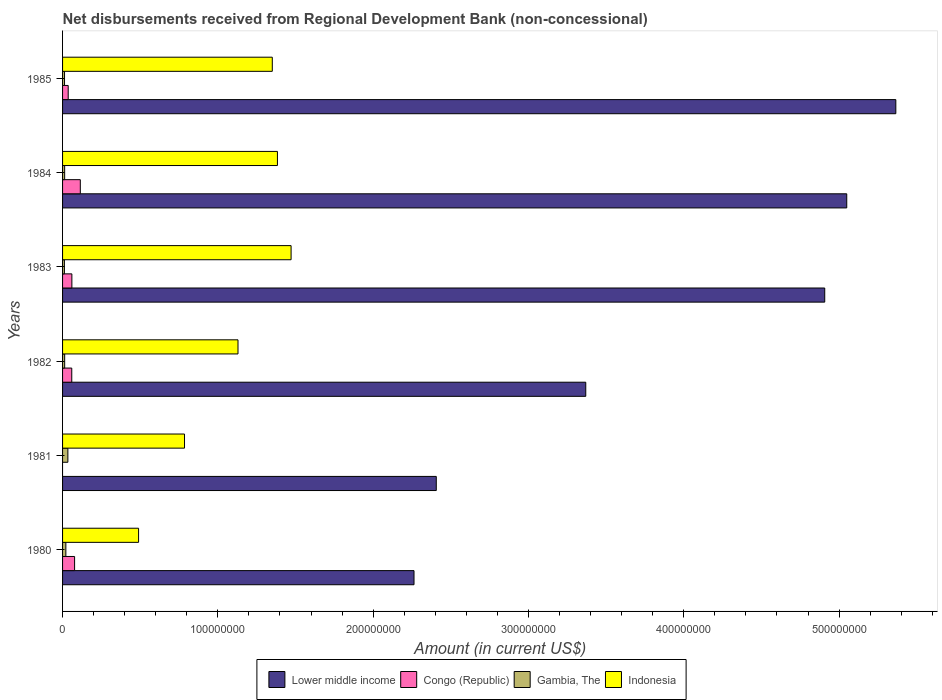Are the number of bars per tick equal to the number of legend labels?
Make the answer very short. No. Are the number of bars on each tick of the Y-axis equal?
Keep it short and to the point. No. What is the label of the 2nd group of bars from the top?
Make the answer very short. 1984. What is the amount of disbursements received from Regional Development Bank in Lower middle income in 1981?
Your answer should be compact. 2.41e+08. Across all years, what is the maximum amount of disbursements received from Regional Development Bank in Lower middle income?
Keep it short and to the point. 5.37e+08. Across all years, what is the minimum amount of disbursements received from Regional Development Bank in Gambia, The?
Your response must be concise. 1.18e+06. In which year was the amount of disbursements received from Regional Development Bank in Indonesia maximum?
Offer a terse response. 1983. What is the total amount of disbursements received from Regional Development Bank in Indonesia in the graph?
Provide a succinct answer. 6.61e+08. What is the difference between the amount of disbursements received from Regional Development Bank in Congo (Republic) in 1982 and that in 1984?
Offer a very short reply. -5.50e+06. What is the difference between the amount of disbursements received from Regional Development Bank in Congo (Republic) in 1985 and the amount of disbursements received from Regional Development Bank in Indonesia in 1983?
Offer a terse response. -1.44e+08. What is the average amount of disbursements received from Regional Development Bank in Gambia, The per year?
Keep it short and to the point. 1.78e+06. In the year 1980, what is the difference between the amount of disbursements received from Regional Development Bank in Gambia, The and amount of disbursements received from Regional Development Bank in Congo (Republic)?
Give a very brief answer. -5.63e+06. In how many years, is the amount of disbursements received from Regional Development Bank in Gambia, The greater than 140000000 US$?
Your answer should be compact. 0. What is the ratio of the amount of disbursements received from Regional Development Bank in Congo (Republic) in 1982 to that in 1983?
Your answer should be very brief. 0.99. Is the amount of disbursements received from Regional Development Bank in Indonesia in 1984 less than that in 1985?
Offer a terse response. No. Is the difference between the amount of disbursements received from Regional Development Bank in Gambia, The in 1983 and 1984 greater than the difference between the amount of disbursements received from Regional Development Bank in Congo (Republic) in 1983 and 1984?
Keep it short and to the point. Yes. What is the difference between the highest and the second highest amount of disbursements received from Regional Development Bank in Congo (Republic)?
Your answer should be compact. 3.68e+06. What is the difference between the highest and the lowest amount of disbursements received from Regional Development Bank in Indonesia?
Offer a terse response. 9.82e+07. How many bars are there?
Provide a short and direct response. 23. How many years are there in the graph?
Keep it short and to the point. 6. What is the difference between two consecutive major ticks on the X-axis?
Your answer should be compact. 1.00e+08. Does the graph contain grids?
Ensure brevity in your answer.  No. Where does the legend appear in the graph?
Your answer should be very brief. Bottom center. How many legend labels are there?
Ensure brevity in your answer.  4. How are the legend labels stacked?
Give a very brief answer. Horizontal. What is the title of the graph?
Offer a very short reply. Net disbursements received from Regional Development Bank (non-concessional). Does "Micronesia" appear as one of the legend labels in the graph?
Ensure brevity in your answer.  No. What is the label or title of the X-axis?
Give a very brief answer. Amount (in current US$). What is the Amount (in current US$) in Lower middle income in 1980?
Offer a very short reply. 2.26e+08. What is the Amount (in current US$) in Congo (Republic) in 1980?
Your response must be concise. 7.74e+06. What is the Amount (in current US$) of Gambia, The in 1980?
Provide a short and direct response. 2.12e+06. What is the Amount (in current US$) in Indonesia in 1980?
Keep it short and to the point. 4.89e+07. What is the Amount (in current US$) in Lower middle income in 1981?
Offer a very short reply. 2.41e+08. What is the Amount (in current US$) in Congo (Republic) in 1981?
Offer a terse response. 0. What is the Amount (in current US$) in Gambia, The in 1981?
Provide a short and direct response. 3.42e+06. What is the Amount (in current US$) of Indonesia in 1981?
Your answer should be compact. 7.85e+07. What is the Amount (in current US$) of Lower middle income in 1982?
Offer a terse response. 3.37e+08. What is the Amount (in current US$) in Congo (Republic) in 1982?
Offer a terse response. 5.92e+06. What is the Amount (in current US$) of Gambia, The in 1982?
Your response must be concise. 1.36e+06. What is the Amount (in current US$) of Indonesia in 1982?
Keep it short and to the point. 1.13e+08. What is the Amount (in current US$) of Lower middle income in 1983?
Give a very brief answer. 4.91e+08. What is the Amount (in current US$) in Congo (Republic) in 1983?
Provide a succinct answer. 6.00e+06. What is the Amount (in current US$) in Gambia, The in 1983?
Ensure brevity in your answer.  1.18e+06. What is the Amount (in current US$) in Indonesia in 1983?
Your answer should be compact. 1.47e+08. What is the Amount (in current US$) of Lower middle income in 1984?
Offer a terse response. 5.05e+08. What is the Amount (in current US$) in Congo (Republic) in 1984?
Your answer should be compact. 1.14e+07. What is the Amount (in current US$) of Gambia, The in 1984?
Provide a short and direct response. 1.35e+06. What is the Amount (in current US$) in Indonesia in 1984?
Offer a terse response. 1.38e+08. What is the Amount (in current US$) of Lower middle income in 1985?
Make the answer very short. 5.37e+08. What is the Amount (in current US$) in Congo (Republic) in 1985?
Your answer should be very brief. 3.63e+06. What is the Amount (in current US$) of Gambia, The in 1985?
Provide a short and direct response. 1.26e+06. What is the Amount (in current US$) of Indonesia in 1985?
Your answer should be compact. 1.35e+08. Across all years, what is the maximum Amount (in current US$) in Lower middle income?
Provide a short and direct response. 5.37e+08. Across all years, what is the maximum Amount (in current US$) of Congo (Republic)?
Your answer should be very brief. 1.14e+07. Across all years, what is the maximum Amount (in current US$) in Gambia, The?
Your response must be concise. 3.42e+06. Across all years, what is the maximum Amount (in current US$) of Indonesia?
Ensure brevity in your answer.  1.47e+08. Across all years, what is the minimum Amount (in current US$) of Lower middle income?
Your response must be concise. 2.26e+08. Across all years, what is the minimum Amount (in current US$) of Gambia, The?
Your answer should be very brief. 1.18e+06. Across all years, what is the minimum Amount (in current US$) of Indonesia?
Give a very brief answer. 4.89e+07. What is the total Amount (in current US$) of Lower middle income in the graph?
Your answer should be compact. 2.34e+09. What is the total Amount (in current US$) in Congo (Republic) in the graph?
Provide a short and direct response. 3.47e+07. What is the total Amount (in current US$) in Gambia, The in the graph?
Offer a terse response. 1.07e+07. What is the total Amount (in current US$) of Indonesia in the graph?
Provide a succinct answer. 6.61e+08. What is the difference between the Amount (in current US$) of Lower middle income in 1980 and that in 1981?
Offer a very short reply. -1.43e+07. What is the difference between the Amount (in current US$) in Gambia, The in 1980 and that in 1981?
Offer a very short reply. -1.30e+06. What is the difference between the Amount (in current US$) of Indonesia in 1980 and that in 1981?
Provide a short and direct response. -2.96e+07. What is the difference between the Amount (in current US$) of Lower middle income in 1980 and that in 1982?
Give a very brief answer. -1.11e+08. What is the difference between the Amount (in current US$) in Congo (Republic) in 1980 and that in 1982?
Keep it short and to the point. 1.82e+06. What is the difference between the Amount (in current US$) of Gambia, The in 1980 and that in 1982?
Your response must be concise. 7.58e+05. What is the difference between the Amount (in current US$) of Indonesia in 1980 and that in 1982?
Provide a short and direct response. -6.40e+07. What is the difference between the Amount (in current US$) in Lower middle income in 1980 and that in 1983?
Your answer should be very brief. -2.64e+08. What is the difference between the Amount (in current US$) of Congo (Republic) in 1980 and that in 1983?
Make the answer very short. 1.75e+06. What is the difference between the Amount (in current US$) in Gambia, The in 1980 and that in 1983?
Your answer should be very brief. 9.31e+05. What is the difference between the Amount (in current US$) of Indonesia in 1980 and that in 1983?
Provide a succinct answer. -9.82e+07. What is the difference between the Amount (in current US$) in Lower middle income in 1980 and that in 1984?
Your answer should be very brief. -2.79e+08. What is the difference between the Amount (in current US$) of Congo (Republic) in 1980 and that in 1984?
Ensure brevity in your answer.  -3.68e+06. What is the difference between the Amount (in current US$) in Gambia, The in 1980 and that in 1984?
Offer a terse response. 7.68e+05. What is the difference between the Amount (in current US$) in Indonesia in 1980 and that in 1984?
Ensure brevity in your answer.  -8.94e+07. What is the difference between the Amount (in current US$) in Lower middle income in 1980 and that in 1985?
Provide a succinct answer. -3.10e+08. What is the difference between the Amount (in current US$) of Congo (Republic) in 1980 and that in 1985?
Your answer should be compact. 4.12e+06. What is the difference between the Amount (in current US$) of Gambia, The in 1980 and that in 1985?
Your response must be concise. 8.53e+05. What is the difference between the Amount (in current US$) in Indonesia in 1980 and that in 1985?
Make the answer very short. -8.61e+07. What is the difference between the Amount (in current US$) of Lower middle income in 1981 and that in 1982?
Offer a very short reply. -9.63e+07. What is the difference between the Amount (in current US$) in Gambia, The in 1981 and that in 1982?
Offer a very short reply. 2.06e+06. What is the difference between the Amount (in current US$) of Indonesia in 1981 and that in 1982?
Provide a short and direct response. -3.44e+07. What is the difference between the Amount (in current US$) of Lower middle income in 1981 and that in 1983?
Provide a succinct answer. -2.50e+08. What is the difference between the Amount (in current US$) in Gambia, The in 1981 and that in 1983?
Provide a succinct answer. 2.23e+06. What is the difference between the Amount (in current US$) in Indonesia in 1981 and that in 1983?
Offer a terse response. -6.86e+07. What is the difference between the Amount (in current US$) in Lower middle income in 1981 and that in 1984?
Give a very brief answer. -2.64e+08. What is the difference between the Amount (in current US$) in Gambia, The in 1981 and that in 1984?
Ensure brevity in your answer.  2.07e+06. What is the difference between the Amount (in current US$) in Indonesia in 1981 and that in 1984?
Your response must be concise. -5.98e+07. What is the difference between the Amount (in current US$) in Lower middle income in 1981 and that in 1985?
Give a very brief answer. -2.96e+08. What is the difference between the Amount (in current US$) of Gambia, The in 1981 and that in 1985?
Provide a succinct answer. 2.16e+06. What is the difference between the Amount (in current US$) of Indonesia in 1981 and that in 1985?
Provide a succinct answer. -5.65e+07. What is the difference between the Amount (in current US$) in Lower middle income in 1982 and that in 1983?
Your response must be concise. -1.54e+08. What is the difference between the Amount (in current US$) in Congo (Republic) in 1982 and that in 1983?
Provide a succinct answer. -7.30e+04. What is the difference between the Amount (in current US$) of Gambia, The in 1982 and that in 1983?
Your response must be concise. 1.73e+05. What is the difference between the Amount (in current US$) in Indonesia in 1982 and that in 1983?
Provide a succinct answer. -3.42e+07. What is the difference between the Amount (in current US$) of Lower middle income in 1982 and that in 1984?
Give a very brief answer. -1.68e+08. What is the difference between the Amount (in current US$) of Congo (Republic) in 1982 and that in 1984?
Make the answer very short. -5.50e+06. What is the difference between the Amount (in current US$) of Gambia, The in 1982 and that in 1984?
Give a very brief answer. 10000. What is the difference between the Amount (in current US$) in Indonesia in 1982 and that in 1984?
Ensure brevity in your answer.  -2.54e+07. What is the difference between the Amount (in current US$) in Lower middle income in 1982 and that in 1985?
Ensure brevity in your answer.  -2.00e+08. What is the difference between the Amount (in current US$) in Congo (Republic) in 1982 and that in 1985?
Offer a terse response. 2.30e+06. What is the difference between the Amount (in current US$) in Gambia, The in 1982 and that in 1985?
Make the answer very short. 9.50e+04. What is the difference between the Amount (in current US$) in Indonesia in 1982 and that in 1985?
Keep it short and to the point. -2.21e+07. What is the difference between the Amount (in current US$) in Lower middle income in 1983 and that in 1984?
Your answer should be compact. -1.42e+07. What is the difference between the Amount (in current US$) of Congo (Republic) in 1983 and that in 1984?
Your response must be concise. -5.43e+06. What is the difference between the Amount (in current US$) in Gambia, The in 1983 and that in 1984?
Provide a succinct answer. -1.63e+05. What is the difference between the Amount (in current US$) in Indonesia in 1983 and that in 1984?
Your response must be concise. 8.79e+06. What is the difference between the Amount (in current US$) in Lower middle income in 1983 and that in 1985?
Make the answer very short. -4.58e+07. What is the difference between the Amount (in current US$) in Congo (Republic) in 1983 and that in 1985?
Your answer should be very brief. 2.37e+06. What is the difference between the Amount (in current US$) in Gambia, The in 1983 and that in 1985?
Offer a terse response. -7.80e+04. What is the difference between the Amount (in current US$) in Indonesia in 1983 and that in 1985?
Make the answer very short. 1.21e+07. What is the difference between the Amount (in current US$) of Lower middle income in 1984 and that in 1985?
Provide a succinct answer. -3.16e+07. What is the difference between the Amount (in current US$) in Congo (Republic) in 1984 and that in 1985?
Your answer should be very brief. 7.80e+06. What is the difference between the Amount (in current US$) in Gambia, The in 1984 and that in 1985?
Your answer should be compact. 8.50e+04. What is the difference between the Amount (in current US$) of Indonesia in 1984 and that in 1985?
Provide a succinct answer. 3.32e+06. What is the difference between the Amount (in current US$) in Lower middle income in 1980 and the Amount (in current US$) in Gambia, The in 1981?
Ensure brevity in your answer.  2.23e+08. What is the difference between the Amount (in current US$) of Lower middle income in 1980 and the Amount (in current US$) of Indonesia in 1981?
Make the answer very short. 1.48e+08. What is the difference between the Amount (in current US$) in Congo (Republic) in 1980 and the Amount (in current US$) in Gambia, The in 1981?
Offer a very short reply. 4.33e+06. What is the difference between the Amount (in current US$) in Congo (Republic) in 1980 and the Amount (in current US$) in Indonesia in 1981?
Ensure brevity in your answer.  -7.08e+07. What is the difference between the Amount (in current US$) of Gambia, The in 1980 and the Amount (in current US$) of Indonesia in 1981?
Offer a very short reply. -7.64e+07. What is the difference between the Amount (in current US$) in Lower middle income in 1980 and the Amount (in current US$) in Congo (Republic) in 1982?
Make the answer very short. 2.20e+08. What is the difference between the Amount (in current US$) in Lower middle income in 1980 and the Amount (in current US$) in Gambia, The in 1982?
Keep it short and to the point. 2.25e+08. What is the difference between the Amount (in current US$) of Lower middle income in 1980 and the Amount (in current US$) of Indonesia in 1982?
Provide a succinct answer. 1.13e+08. What is the difference between the Amount (in current US$) in Congo (Republic) in 1980 and the Amount (in current US$) in Gambia, The in 1982?
Provide a short and direct response. 6.39e+06. What is the difference between the Amount (in current US$) in Congo (Republic) in 1980 and the Amount (in current US$) in Indonesia in 1982?
Your response must be concise. -1.05e+08. What is the difference between the Amount (in current US$) in Gambia, The in 1980 and the Amount (in current US$) in Indonesia in 1982?
Your answer should be compact. -1.11e+08. What is the difference between the Amount (in current US$) in Lower middle income in 1980 and the Amount (in current US$) in Congo (Republic) in 1983?
Your response must be concise. 2.20e+08. What is the difference between the Amount (in current US$) in Lower middle income in 1980 and the Amount (in current US$) in Gambia, The in 1983?
Make the answer very short. 2.25e+08. What is the difference between the Amount (in current US$) of Lower middle income in 1980 and the Amount (in current US$) of Indonesia in 1983?
Your answer should be very brief. 7.92e+07. What is the difference between the Amount (in current US$) in Congo (Republic) in 1980 and the Amount (in current US$) in Gambia, The in 1983?
Your response must be concise. 6.56e+06. What is the difference between the Amount (in current US$) of Congo (Republic) in 1980 and the Amount (in current US$) of Indonesia in 1983?
Offer a terse response. -1.39e+08. What is the difference between the Amount (in current US$) in Gambia, The in 1980 and the Amount (in current US$) in Indonesia in 1983?
Ensure brevity in your answer.  -1.45e+08. What is the difference between the Amount (in current US$) of Lower middle income in 1980 and the Amount (in current US$) of Congo (Republic) in 1984?
Provide a succinct answer. 2.15e+08. What is the difference between the Amount (in current US$) of Lower middle income in 1980 and the Amount (in current US$) of Gambia, The in 1984?
Offer a terse response. 2.25e+08. What is the difference between the Amount (in current US$) in Lower middle income in 1980 and the Amount (in current US$) in Indonesia in 1984?
Your answer should be very brief. 8.79e+07. What is the difference between the Amount (in current US$) in Congo (Republic) in 1980 and the Amount (in current US$) in Gambia, The in 1984?
Keep it short and to the point. 6.40e+06. What is the difference between the Amount (in current US$) in Congo (Republic) in 1980 and the Amount (in current US$) in Indonesia in 1984?
Ensure brevity in your answer.  -1.31e+08. What is the difference between the Amount (in current US$) of Gambia, The in 1980 and the Amount (in current US$) of Indonesia in 1984?
Your answer should be compact. -1.36e+08. What is the difference between the Amount (in current US$) in Lower middle income in 1980 and the Amount (in current US$) in Congo (Republic) in 1985?
Provide a succinct answer. 2.23e+08. What is the difference between the Amount (in current US$) of Lower middle income in 1980 and the Amount (in current US$) of Gambia, The in 1985?
Your answer should be very brief. 2.25e+08. What is the difference between the Amount (in current US$) in Lower middle income in 1980 and the Amount (in current US$) in Indonesia in 1985?
Your answer should be very brief. 9.13e+07. What is the difference between the Amount (in current US$) in Congo (Republic) in 1980 and the Amount (in current US$) in Gambia, The in 1985?
Provide a short and direct response. 6.48e+06. What is the difference between the Amount (in current US$) in Congo (Republic) in 1980 and the Amount (in current US$) in Indonesia in 1985?
Give a very brief answer. -1.27e+08. What is the difference between the Amount (in current US$) in Gambia, The in 1980 and the Amount (in current US$) in Indonesia in 1985?
Provide a short and direct response. -1.33e+08. What is the difference between the Amount (in current US$) in Lower middle income in 1981 and the Amount (in current US$) in Congo (Republic) in 1982?
Ensure brevity in your answer.  2.35e+08. What is the difference between the Amount (in current US$) of Lower middle income in 1981 and the Amount (in current US$) of Gambia, The in 1982?
Your response must be concise. 2.39e+08. What is the difference between the Amount (in current US$) of Lower middle income in 1981 and the Amount (in current US$) of Indonesia in 1982?
Make the answer very short. 1.28e+08. What is the difference between the Amount (in current US$) of Gambia, The in 1981 and the Amount (in current US$) of Indonesia in 1982?
Your answer should be compact. -1.10e+08. What is the difference between the Amount (in current US$) of Lower middle income in 1981 and the Amount (in current US$) of Congo (Republic) in 1983?
Your answer should be very brief. 2.35e+08. What is the difference between the Amount (in current US$) of Lower middle income in 1981 and the Amount (in current US$) of Gambia, The in 1983?
Your response must be concise. 2.39e+08. What is the difference between the Amount (in current US$) in Lower middle income in 1981 and the Amount (in current US$) in Indonesia in 1983?
Ensure brevity in your answer.  9.35e+07. What is the difference between the Amount (in current US$) in Gambia, The in 1981 and the Amount (in current US$) in Indonesia in 1983?
Offer a very short reply. -1.44e+08. What is the difference between the Amount (in current US$) in Lower middle income in 1981 and the Amount (in current US$) in Congo (Republic) in 1984?
Provide a succinct answer. 2.29e+08. What is the difference between the Amount (in current US$) in Lower middle income in 1981 and the Amount (in current US$) in Gambia, The in 1984?
Ensure brevity in your answer.  2.39e+08. What is the difference between the Amount (in current US$) of Lower middle income in 1981 and the Amount (in current US$) of Indonesia in 1984?
Provide a succinct answer. 1.02e+08. What is the difference between the Amount (in current US$) in Gambia, The in 1981 and the Amount (in current US$) in Indonesia in 1984?
Offer a very short reply. -1.35e+08. What is the difference between the Amount (in current US$) in Lower middle income in 1981 and the Amount (in current US$) in Congo (Republic) in 1985?
Keep it short and to the point. 2.37e+08. What is the difference between the Amount (in current US$) of Lower middle income in 1981 and the Amount (in current US$) of Gambia, The in 1985?
Offer a very short reply. 2.39e+08. What is the difference between the Amount (in current US$) in Lower middle income in 1981 and the Amount (in current US$) in Indonesia in 1985?
Your answer should be compact. 1.06e+08. What is the difference between the Amount (in current US$) of Gambia, The in 1981 and the Amount (in current US$) of Indonesia in 1985?
Your answer should be very brief. -1.32e+08. What is the difference between the Amount (in current US$) of Lower middle income in 1982 and the Amount (in current US$) of Congo (Republic) in 1983?
Your answer should be very brief. 3.31e+08. What is the difference between the Amount (in current US$) of Lower middle income in 1982 and the Amount (in current US$) of Gambia, The in 1983?
Your response must be concise. 3.36e+08. What is the difference between the Amount (in current US$) of Lower middle income in 1982 and the Amount (in current US$) of Indonesia in 1983?
Your answer should be very brief. 1.90e+08. What is the difference between the Amount (in current US$) in Congo (Republic) in 1982 and the Amount (in current US$) in Gambia, The in 1983?
Provide a short and direct response. 4.74e+06. What is the difference between the Amount (in current US$) of Congo (Republic) in 1982 and the Amount (in current US$) of Indonesia in 1983?
Make the answer very short. -1.41e+08. What is the difference between the Amount (in current US$) of Gambia, The in 1982 and the Amount (in current US$) of Indonesia in 1983?
Make the answer very short. -1.46e+08. What is the difference between the Amount (in current US$) in Lower middle income in 1982 and the Amount (in current US$) in Congo (Republic) in 1984?
Provide a succinct answer. 3.25e+08. What is the difference between the Amount (in current US$) of Lower middle income in 1982 and the Amount (in current US$) of Gambia, The in 1984?
Provide a succinct answer. 3.36e+08. What is the difference between the Amount (in current US$) of Lower middle income in 1982 and the Amount (in current US$) of Indonesia in 1984?
Provide a succinct answer. 1.99e+08. What is the difference between the Amount (in current US$) in Congo (Republic) in 1982 and the Amount (in current US$) in Gambia, The in 1984?
Give a very brief answer. 4.57e+06. What is the difference between the Amount (in current US$) of Congo (Republic) in 1982 and the Amount (in current US$) of Indonesia in 1984?
Your answer should be very brief. -1.32e+08. What is the difference between the Amount (in current US$) in Gambia, The in 1982 and the Amount (in current US$) in Indonesia in 1984?
Provide a succinct answer. -1.37e+08. What is the difference between the Amount (in current US$) of Lower middle income in 1982 and the Amount (in current US$) of Congo (Republic) in 1985?
Your response must be concise. 3.33e+08. What is the difference between the Amount (in current US$) of Lower middle income in 1982 and the Amount (in current US$) of Gambia, The in 1985?
Your answer should be compact. 3.36e+08. What is the difference between the Amount (in current US$) in Lower middle income in 1982 and the Amount (in current US$) in Indonesia in 1985?
Your answer should be compact. 2.02e+08. What is the difference between the Amount (in current US$) in Congo (Republic) in 1982 and the Amount (in current US$) in Gambia, The in 1985?
Keep it short and to the point. 4.66e+06. What is the difference between the Amount (in current US$) in Congo (Republic) in 1982 and the Amount (in current US$) in Indonesia in 1985?
Your answer should be compact. -1.29e+08. What is the difference between the Amount (in current US$) in Gambia, The in 1982 and the Amount (in current US$) in Indonesia in 1985?
Give a very brief answer. -1.34e+08. What is the difference between the Amount (in current US$) in Lower middle income in 1983 and the Amount (in current US$) in Congo (Republic) in 1984?
Offer a very short reply. 4.79e+08. What is the difference between the Amount (in current US$) of Lower middle income in 1983 and the Amount (in current US$) of Gambia, The in 1984?
Your response must be concise. 4.89e+08. What is the difference between the Amount (in current US$) of Lower middle income in 1983 and the Amount (in current US$) of Indonesia in 1984?
Your answer should be very brief. 3.52e+08. What is the difference between the Amount (in current US$) in Congo (Republic) in 1983 and the Amount (in current US$) in Gambia, The in 1984?
Your answer should be compact. 4.65e+06. What is the difference between the Amount (in current US$) in Congo (Republic) in 1983 and the Amount (in current US$) in Indonesia in 1984?
Your answer should be compact. -1.32e+08. What is the difference between the Amount (in current US$) of Gambia, The in 1983 and the Amount (in current US$) of Indonesia in 1984?
Your answer should be compact. -1.37e+08. What is the difference between the Amount (in current US$) in Lower middle income in 1983 and the Amount (in current US$) in Congo (Republic) in 1985?
Provide a short and direct response. 4.87e+08. What is the difference between the Amount (in current US$) in Lower middle income in 1983 and the Amount (in current US$) in Gambia, The in 1985?
Keep it short and to the point. 4.90e+08. What is the difference between the Amount (in current US$) in Lower middle income in 1983 and the Amount (in current US$) in Indonesia in 1985?
Offer a very short reply. 3.56e+08. What is the difference between the Amount (in current US$) of Congo (Republic) in 1983 and the Amount (in current US$) of Gambia, The in 1985?
Provide a succinct answer. 4.73e+06. What is the difference between the Amount (in current US$) of Congo (Republic) in 1983 and the Amount (in current US$) of Indonesia in 1985?
Your answer should be very brief. -1.29e+08. What is the difference between the Amount (in current US$) in Gambia, The in 1983 and the Amount (in current US$) in Indonesia in 1985?
Your answer should be compact. -1.34e+08. What is the difference between the Amount (in current US$) of Lower middle income in 1984 and the Amount (in current US$) of Congo (Republic) in 1985?
Provide a short and direct response. 5.01e+08. What is the difference between the Amount (in current US$) of Lower middle income in 1984 and the Amount (in current US$) of Gambia, The in 1985?
Make the answer very short. 5.04e+08. What is the difference between the Amount (in current US$) in Lower middle income in 1984 and the Amount (in current US$) in Indonesia in 1985?
Give a very brief answer. 3.70e+08. What is the difference between the Amount (in current US$) of Congo (Republic) in 1984 and the Amount (in current US$) of Gambia, The in 1985?
Your answer should be very brief. 1.02e+07. What is the difference between the Amount (in current US$) in Congo (Republic) in 1984 and the Amount (in current US$) in Indonesia in 1985?
Your answer should be compact. -1.24e+08. What is the difference between the Amount (in current US$) of Gambia, The in 1984 and the Amount (in current US$) of Indonesia in 1985?
Provide a succinct answer. -1.34e+08. What is the average Amount (in current US$) in Lower middle income per year?
Your answer should be compact. 3.89e+08. What is the average Amount (in current US$) of Congo (Republic) per year?
Keep it short and to the point. 5.79e+06. What is the average Amount (in current US$) in Gambia, The per year?
Your answer should be compact. 1.78e+06. What is the average Amount (in current US$) of Indonesia per year?
Provide a succinct answer. 1.10e+08. In the year 1980, what is the difference between the Amount (in current US$) of Lower middle income and Amount (in current US$) of Congo (Republic)?
Provide a succinct answer. 2.19e+08. In the year 1980, what is the difference between the Amount (in current US$) of Lower middle income and Amount (in current US$) of Gambia, The?
Your answer should be very brief. 2.24e+08. In the year 1980, what is the difference between the Amount (in current US$) in Lower middle income and Amount (in current US$) in Indonesia?
Your answer should be compact. 1.77e+08. In the year 1980, what is the difference between the Amount (in current US$) of Congo (Republic) and Amount (in current US$) of Gambia, The?
Your answer should be very brief. 5.63e+06. In the year 1980, what is the difference between the Amount (in current US$) in Congo (Republic) and Amount (in current US$) in Indonesia?
Your answer should be very brief. -4.12e+07. In the year 1980, what is the difference between the Amount (in current US$) in Gambia, The and Amount (in current US$) in Indonesia?
Make the answer very short. -4.68e+07. In the year 1981, what is the difference between the Amount (in current US$) of Lower middle income and Amount (in current US$) of Gambia, The?
Your response must be concise. 2.37e+08. In the year 1981, what is the difference between the Amount (in current US$) in Lower middle income and Amount (in current US$) in Indonesia?
Your response must be concise. 1.62e+08. In the year 1981, what is the difference between the Amount (in current US$) in Gambia, The and Amount (in current US$) in Indonesia?
Ensure brevity in your answer.  -7.51e+07. In the year 1982, what is the difference between the Amount (in current US$) of Lower middle income and Amount (in current US$) of Congo (Republic)?
Offer a terse response. 3.31e+08. In the year 1982, what is the difference between the Amount (in current US$) of Lower middle income and Amount (in current US$) of Gambia, The?
Provide a short and direct response. 3.36e+08. In the year 1982, what is the difference between the Amount (in current US$) of Lower middle income and Amount (in current US$) of Indonesia?
Ensure brevity in your answer.  2.24e+08. In the year 1982, what is the difference between the Amount (in current US$) of Congo (Republic) and Amount (in current US$) of Gambia, The?
Offer a very short reply. 4.56e+06. In the year 1982, what is the difference between the Amount (in current US$) in Congo (Republic) and Amount (in current US$) in Indonesia?
Provide a short and direct response. -1.07e+08. In the year 1982, what is the difference between the Amount (in current US$) of Gambia, The and Amount (in current US$) of Indonesia?
Offer a terse response. -1.12e+08. In the year 1983, what is the difference between the Amount (in current US$) in Lower middle income and Amount (in current US$) in Congo (Republic)?
Your answer should be compact. 4.85e+08. In the year 1983, what is the difference between the Amount (in current US$) in Lower middle income and Amount (in current US$) in Gambia, The?
Your response must be concise. 4.90e+08. In the year 1983, what is the difference between the Amount (in current US$) in Lower middle income and Amount (in current US$) in Indonesia?
Your answer should be compact. 3.44e+08. In the year 1983, what is the difference between the Amount (in current US$) in Congo (Republic) and Amount (in current US$) in Gambia, The?
Ensure brevity in your answer.  4.81e+06. In the year 1983, what is the difference between the Amount (in current US$) in Congo (Republic) and Amount (in current US$) in Indonesia?
Keep it short and to the point. -1.41e+08. In the year 1983, what is the difference between the Amount (in current US$) in Gambia, The and Amount (in current US$) in Indonesia?
Keep it short and to the point. -1.46e+08. In the year 1984, what is the difference between the Amount (in current US$) of Lower middle income and Amount (in current US$) of Congo (Republic)?
Give a very brief answer. 4.94e+08. In the year 1984, what is the difference between the Amount (in current US$) in Lower middle income and Amount (in current US$) in Gambia, The?
Provide a short and direct response. 5.04e+08. In the year 1984, what is the difference between the Amount (in current US$) in Lower middle income and Amount (in current US$) in Indonesia?
Ensure brevity in your answer.  3.67e+08. In the year 1984, what is the difference between the Amount (in current US$) of Congo (Republic) and Amount (in current US$) of Gambia, The?
Provide a short and direct response. 1.01e+07. In the year 1984, what is the difference between the Amount (in current US$) in Congo (Republic) and Amount (in current US$) in Indonesia?
Your answer should be compact. -1.27e+08. In the year 1984, what is the difference between the Amount (in current US$) in Gambia, The and Amount (in current US$) in Indonesia?
Your answer should be very brief. -1.37e+08. In the year 1985, what is the difference between the Amount (in current US$) in Lower middle income and Amount (in current US$) in Congo (Republic)?
Make the answer very short. 5.33e+08. In the year 1985, what is the difference between the Amount (in current US$) of Lower middle income and Amount (in current US$) of Gambia, The?
Keep it short and to the point. 5.35e+08. In the year 1985, what is the difference between the Amount (in current US$) in Lower middle income and Amount (in current US$) in Indonesia?
Give a very brief answer. 4.01e+08. In the year 1985, what is the difference between the Amount (in current US$) of Congo (Republic) and Amount (in current US$) of Gambia, The?
Your response must be concise. 2.36e+06. In the year 1985, what is the difference between the Amount (in current US$) of Congo (Republic) and Amount (in current US$) of Indonesia?
Offer a terse response. -1.31e+08. In the year 1985, what is the difference between the Amount (in current US$) of Gambia, The and Amount (in current US$) of Indonesia?
Make the answer very short. -1.34e+08. What is the ratio of the Amount (in current US$) of Lower middle income in 1980 to that in 1981?
Provide a succinct answer. 0.94. What is the ratio of the Amount (in current US$) of Gambia, The in 1980 to that in 1981?
Keep it short and to the point. 0.62. What is the ratio of the Amount (in current US$) of Indonesia in 1980 to that in 1981?
Ensure brevity in your answer.  0.62. What is the ratio of the Amount (in current US$) in Lower middle income in 1980 to that in 1982?
Ensure brevity in your answer.  0.67. What is the ratio of the Amount (in current US$) of Congo (Republic) in 1980 to that in 1982?
Ensure brevity in your answer.  1.31. What is the ratio of the Amount (in current US$) in Gambia, The in 1980 to that in 1982?
Ensure brevity in your answer.  1.56. What is the ratio of the Amount (in current US$) in Indonesia in 1980 to that in 1982?
Your answer should be very brief. 0.43. What is the ratio of the Amount (in current US$) in Lower middle income in 1980 to that in 1983?
Keep it short and to the point. 0.46. What is the ratio of the Amount (in current US$) in Congo (Republic) in 1980 to that in 1983?
Your answer should be compact. 1.29. What is the ratio of the Amount (in current US$) of Gambia, The in 1980 to that in 1983?
Your answer should be very brief. 1.79. What is the ratio of the Amount (in current US$) of Indonesia in 1980 to that in 1983?
Ensure brevity in your answer.  0.33. What is the ratio of the Amount (in current US$) in Lower middle income in 1980 to that in 1984?
Provide a succinct answer. 0.45. What is the ratio of the Amount (in current US$) in Congo (Republic) in 1980 to that in 1984?
Make the answer very short. 0.68. What is the ratio of the Amount (in current US$) in Gambia, The in 1980 to that in 1984?
Provide a succinct answer. 1.57. What is the ratio of the Amount (in current US$) of Indonesia in 1980 to that in 1984?
Your answer should be very brief. 0.35. What is the ratio of the Amount (in current US$) in Lower middle income in 1980 to that in 1985?
Offer a very short reply. 0.42. What is the ratio of the Amount (in current US$) of Congo (Republic) in 1980 to that in 1985?
Offer a terse response. 2.14. What is the ratio of the Amount (in current US$) of Gambia, The in 1980 to that in 1985?
Ensure brevity in your answer.  1.68. What is the ratio of the Amount (in current US$) in Indonesia in 1980 to that in 1985?
Your answer should be very brief. 0.36. What is the ratio of the Amount (in current US$) in Lower middle income in 1981 to that in 1982?
Ensure brevity in your answer.  0.71. What is the ratio of the Amount (in current US$) of Gambia, The in 1981 to that in 1982?
Provide a succinct answer. 2.52. What is the ratio of the Amount (in current US$) of Indonesia in 1981 to that in 1982?
Your answer should be very brief. 0.7. What is the ratio of the Amount (in current US$) in Lower middle income in 1981 to that in 1983?
Provide a short and direct response. 0.49. What is the ratio of the Amount (in current US$) in Gambia, The in 1981 to that in 1983?
Offer a very short reply. 2.89. What is the ratio of the Amount (in current US$) in Indonesia in 1981 to that in 1983?
Your response must be concise. 0.53. What is the ratio of the Amount (in current US$) in Lower middle income in 1981 to that in 1984?
Your answer should be compact. 0.48. What is the ratio of the Amount (in current US$) of Gambia, The in 1981 to that in 1984?
Ensure brevity in your answer.  2.54. What is the ratio of the Amount (in current US$) in Indonesia in 1981 to that in 1984?
Ensure brevity in your answer.  0.57. What is the ratio of the Amount (in current US$) of Lower middle income in 1981 to that in 1985?
Provide a short and direct response. 0.45. What is the ratio of the Amount (in current US$) of Gambia, The in 1981 to that in 1985?
Give a very brief answer. 2.71. What is the ratio of the Amount (in current US$) in Indonesia in 1981 to that in 1985?
Your response must be concise. 0.58. What is the ratio of the Amount (in current US$) in Lower middle income in 1982 to that in 1983?
Your answer should be compact. 0.69. What is the ratio of the Amount (in current US$) in Congo (Republic) in 1982 to that in 1983?
Provide a short and direct response. 0.99. What is the ratio of the Amount (in current US$) of Gambia, The in 1982 to that in 1983?
Your answer should be very brief. 1.15. What is the ratio of the Amount (in current US$) of Indonesia in 1982 to that in 1983?
Offer a terse response. 0.77. What is the ratio of the Amount (in current US$) in Lower middle income in 1982 to that in 1984?
Provide a short and direct response. 0.67. What is the ratio of the Amount (in current US$) in Congo (Republic) in 1982 to that in 1984?
Keep it short and to the point. 0.52. What is the ratio of the Amount (in current US$) in Gambia, The in 1982 to that in 1984?
Offer a terse response. 1.01. What is the ratio of the Amount (in current US$) in Indonesia in 1982 to that in 1984?
Ensure brevity in your answer.  0.82. What is the ratio of the Amount (in current US$) of Lower middle income in 1982 to that in 1985?
Your answer should be very brief. 0.63. What is the ratio of the Amount (in current US$) of Congo (Republic) in 1982 to that in 1985?
Make the answer very short. 1.63. What is the ratio of the Amount (in current US$) in Gambia, The in 1982 to that in 1985?
Offer a terse response. 1.08. What is the ratio of the Amount (in current US$) of Indonesia in 1982 to that in 1985?
Provide a short and direct response. 0.84. What is the ratio of the Amount (in current US$) of Lower middle income in 1983 to that in 1984?
Give a very brief answer. 0.97. What is the ratio of the Amount (in current US$) of Congo (Republic) in 1983 to that in 1984?
Make the answer very short. 0.52. What is the ratio of the Amount (in current US$) in Gambia, The in 1983 to that in 1984?
Your response must be concise. 0.88. What is the ratio of the Amount (in current US$) in Indonesia in 1983 to that in 1984?
Offer a terse response. 1.06. What is the ratio of the Amount (in current US$) in Lower middle income in 1983 to that in 1985?
Your answer should be very brief. 0.91. What is the ratio of the Amount (in current US$) in Congo (Republic) in 1983 to that in 1985?
Ensure brevity in your answer.  1.65. What is the ratio of the Amount (in current US$) of Gambia, The in 1983 to that in 1985?
Keep it short and to the point. 0.94. What is the ratio of the Amount (in current US$) in Indonesia in 1983 to that in 1985?
Ensure brevity in your answer.  1.09. What is the ratio of the Amount (in current US$) in Lower middle income in 1984 to that in 1985?
Offer a terse response. 0.94. What is the ratio of the Amount (in current US$) in Congo (Republic) in 1984 to that in 1985?
Give a very brief answer. 3.15. What is the ratio of the Amount (in current US$) of Gambia, The in 1984 to that in 1985?
Give a very brief answer. 1.07. What is the ratio of the Amount (in current US$) of Indonesia in 1984 to that in 1985?
Your answer should be compact. 1.02. What is the difference between the highest and the second highest Amount (in current US$) of Lower middle income?
Your answer should be very brief. 3.16e+07. What is the difference between the highest and the second highest Amount (in current US$) in Congo (Republic)?
Your answer should be compact. 3.68e+06. What is the difference between the highest and the second highest Amount (in current US$) in Gambia, The?
Your answer should be very brief. 1.30e+06. What is the difference between the highest and the second highest Amount (in current US$) of Indonesia?
Ensure brevity in your answer.  8.79e+06. What is the difference between the highest and the lowest Amount (in current US$) of Lower middle income?
Ensure brevity in your answer.  3.10e+08. What is the difference between the highest and the lowest Amount (in current US$) of Congo (Republic)?
Keep it short and to the point. 1.14e+07. What is the difference between the highest and the lowest Amount (in current US$) in Gambia, The?
Keep it short and to the point. 2.23e+06. What is the difference between the highest and the lowest Amount (in current US$) of Indonesia?
Your answer should be very brief. 9.82e+07. 